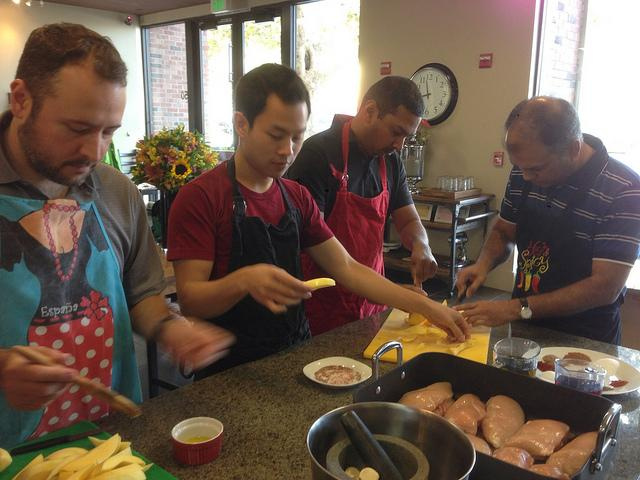What do these people do here?

Choices:
A) sing
B) watch youtube
C) watch tv
D) cook cook 